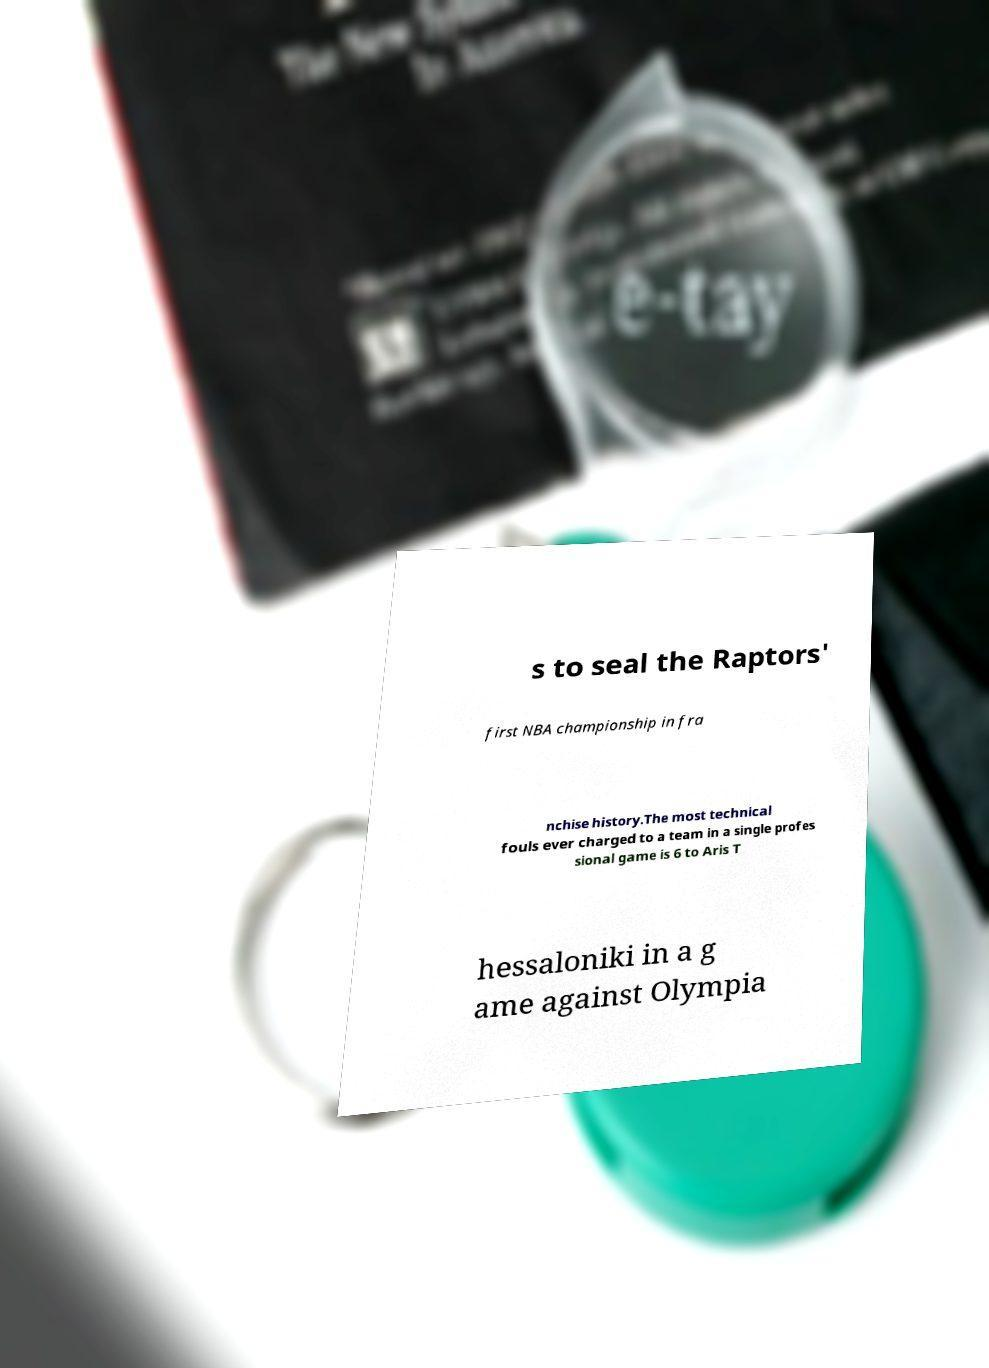There's text embedded in this image that I need extracted. Can you transcribe it verbatim? s to seal the Raptors' first NBA championship in fra nchise history.The most technical fouls ever charged to a team in a single profes sional game is 6 to Aris T hessaloniki in a g ame against Olympia 